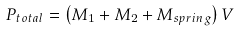<formula> <loc_0><loc_0><loc_500><loc_500>P _ { t o t a l } = \left ( M _ { 1 } + M _ { 2 } + M _ { s p r i n g } \right ) V</formula> 